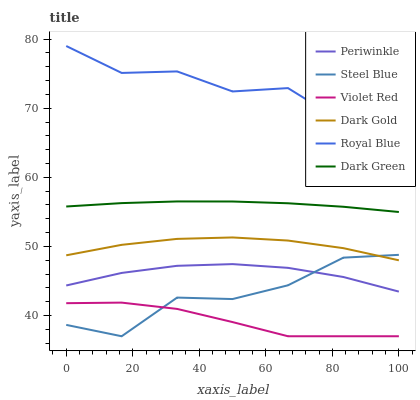Does Violet Red have the minimum area under the curve?
Answer yes or no. Yes. Does Dark Gold have the minimum area under the curve?
Answer yes or no. No. Does Dark Gold have the maximum area under the curve?
Answer yes or no. No. Is Royal Blue the roughest?
Answer yes or no. Yes. Is Dark Gold the smoothest?
Answer yes or no. No. Is Dark Gold the roughest?
Answer yes or no. No. Does Dark Gold have the lowest value?
Answer yes or no. No. Does Dark Gold have the highest value?
Answer yes or no. No. Is Periwinkle less than Royal Blue?
Answer yes or no. Yes. Is Royal Blue greater than Violet Red?
Answer yes or no. Yes. Does Periwinkle intersect Royal Blue?
Answer yes or no. No. 